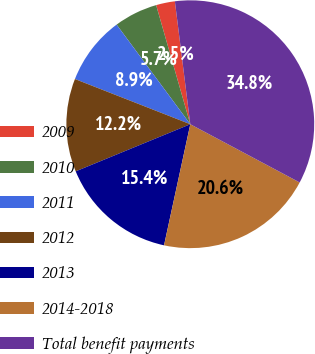Convert chart to OTSL. <chart><loc_0><loc_0><loc_500><loc_500><pie_chart><fcel>2009<fcel>2010<fcel>2011<fcel>2012<fcel>2013<fcel>2014-2018<fcel>Total benefit payments<nl><fcel>2.46%<fcel>5.69%<fcel>8.92%<fcel>12.15%<fcel>15.39%<fcel>20.61%<fcel>34.77%<nl></chart> 